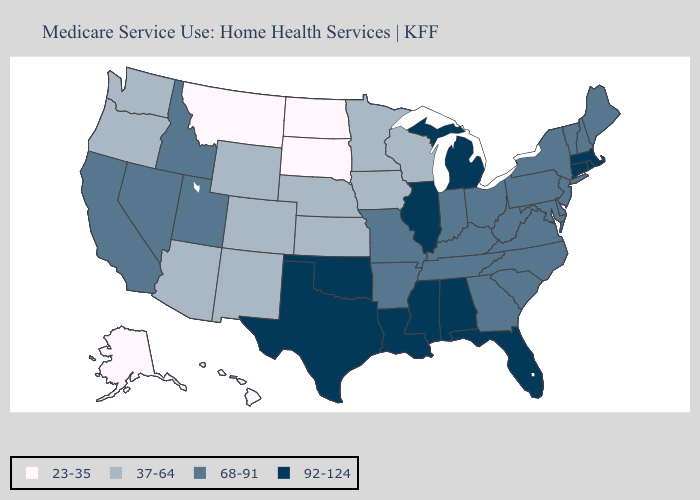What is the value of Michigan?
Be succinct. 92-124. Name the states that have a value in the range 92-124?
Keep it brief. Alabama, Connecticut, Florida, Illinois, Louisiana, Massachusetts, Michigan, Mississippi, Oklahoma, Rhode Island, Texas. What is the value of Oklahoma?
Answer briefly. 92-124. Does the map have missing data?
Write a very short answer. No. What is the value of Minnesota?
Keep it brief. 37-64. Name the states that have a value in the range 37-64?
Give a very brief answer. Arizona, Colorado, Iowa, Kansas, Minnesota, Nebraska, New Mexico, Oregon, Washington, Wisconsin, Wyoming. Does Ohio have the lowest value in the USA?
Concise answer only. No. Among the states that border Tennessee , does Mississippi have the highest value?
Concise answer only. Yes. What is the value of Kansas?
Give a very brief answer. 37-64. What is the value of New Mexico?
Quick response, please. 37-64. Which states have the lowest value in the USA?
Give a very brief answer. Alaska, Hawaii, Montana, North Dakota, South Dakota. Does the map have missing data?
Be succinct. No. What is the value of Nevada?
Keep it brief. 68-91. What is the highest value in the USA?
Concise answer only. 92-124. Among the states that border Kentucky , which have the highest value?
Quick response, please. Illinois. 